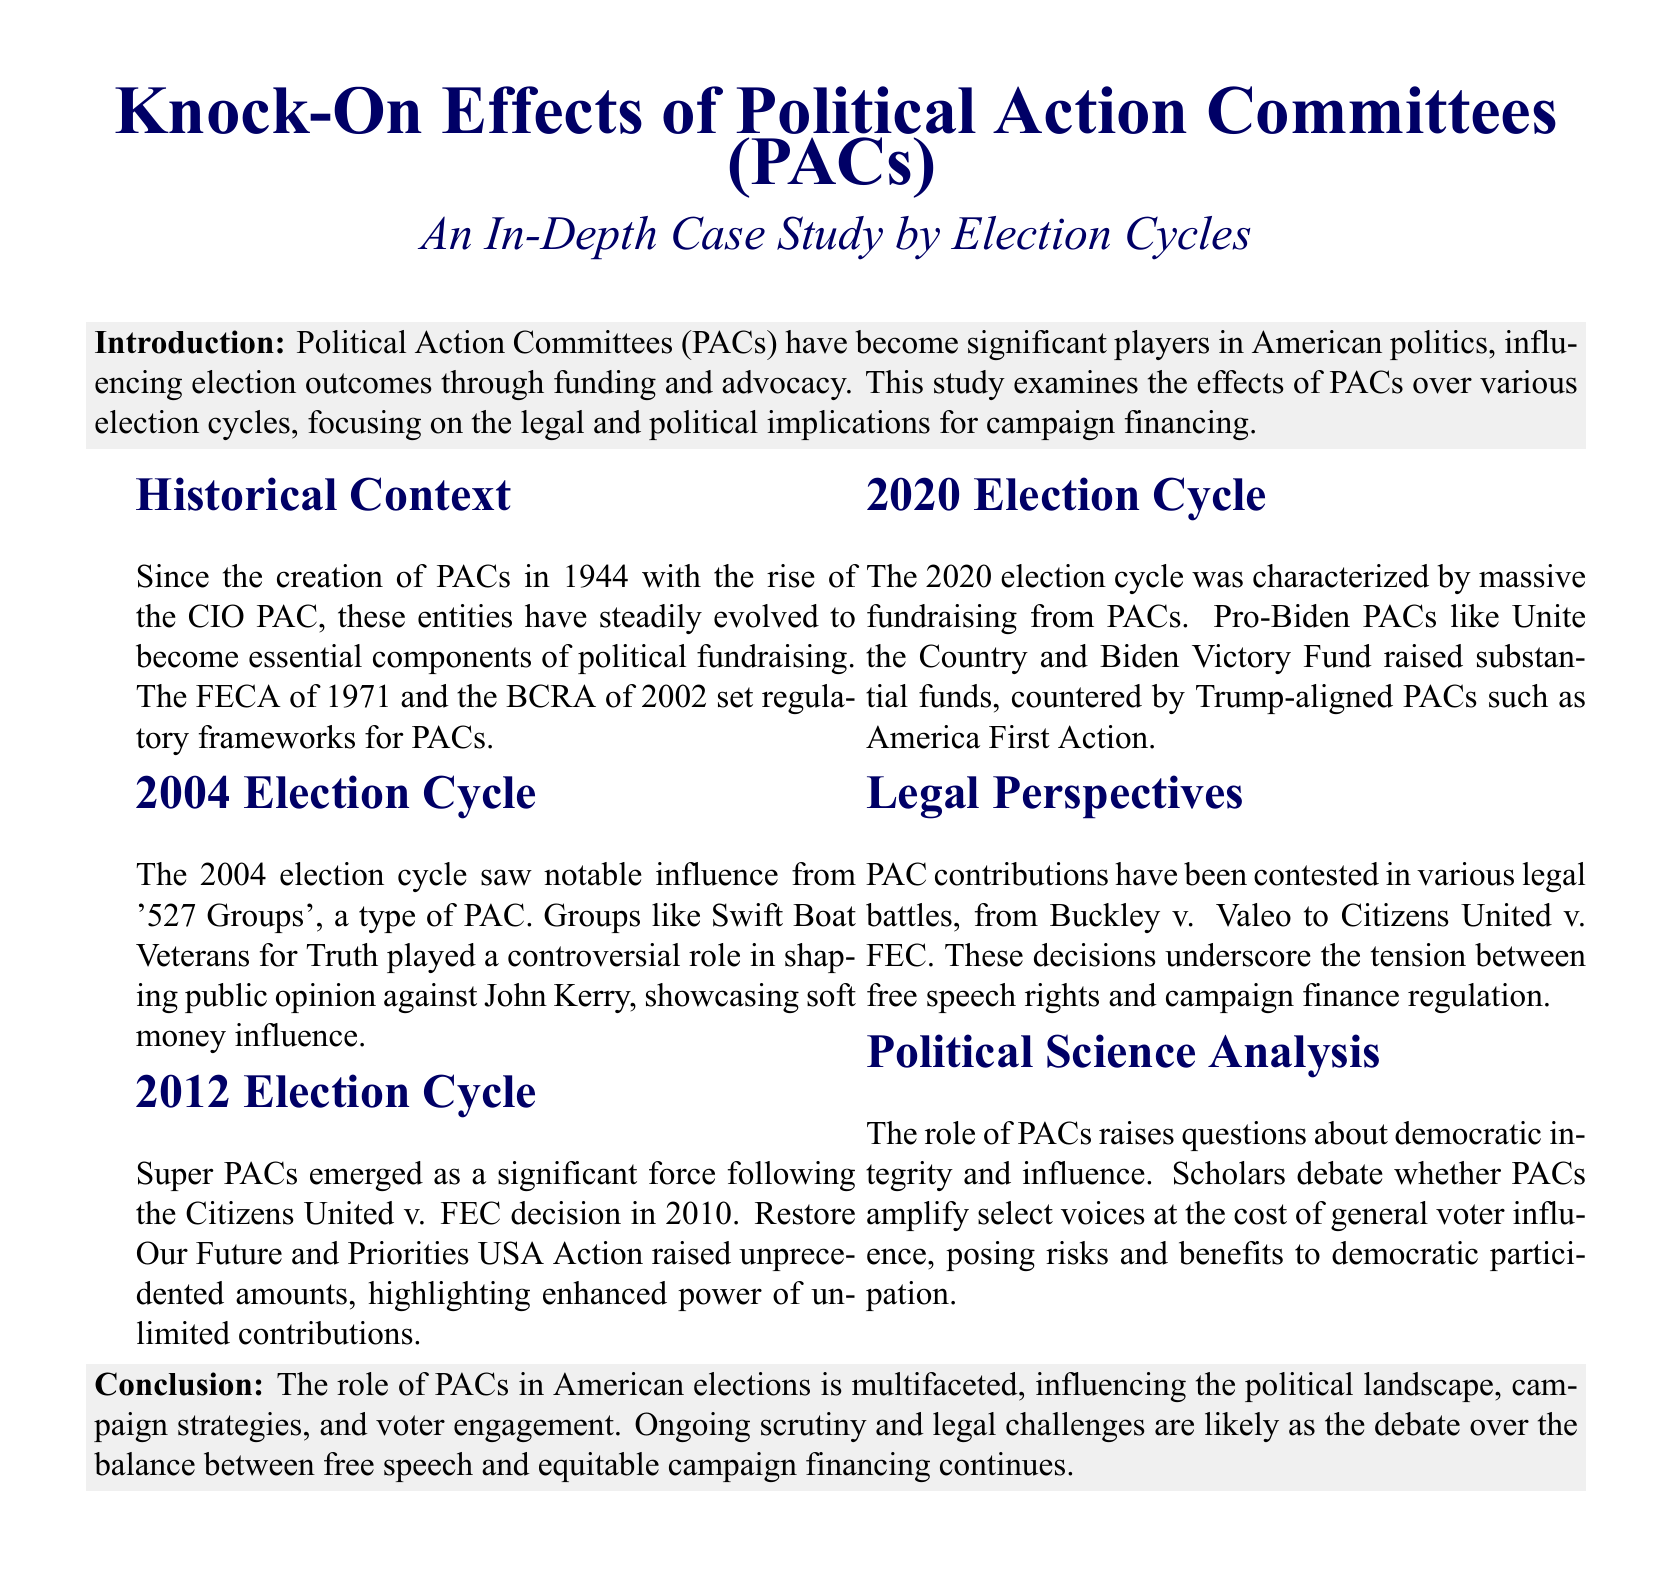What year did PACs originate? The document states that PACs were created in 1944 with the rise of the CIO PAC.
Answer: 1944 What legal case highlighted the power of Super PACs? The case of Citizens United v. FEC, mentioned in the document, underscored the enhanced power of Super PACs.
Answer: Citizens United v. FEC Which PACs were significant in the 2020 election cycle? The document mentions Pro-Biden PACs like Unite the Country and Trump-aligned PACs such as America First Action.
Answer: Unite the Country and America First Action What framework regulates PACs established in 1971? The document notes the Federal Election Campaign Act (FECA) of 1971 established a regulatory framework for PACs.
Answer: FECA What was the role of '527 Groups' in the 2004 election cycle? According to the document, '527 Groups' like Swift Boat Veterans for Truth played a controversial role against John Kerry.
Answer: Controversial role against John Kerry What ongoing issue is mentioned regarding PACs? The document refers to ongoing scrutiny and legal challenges over the debate between free speech and equitable campaign financing.
Answer: Free speech and equitable campaign financing How do PACs affect democratic participation? The document indicates that scholars debate whether PACs amplify select voices at the cost of general voter influence.
Answer: Amplify select voices What was a key characteristic of the 2012 election cycle? The emergence of Super PACs following a key legal decision signifies a notable characteristic of the 2012 election cycle.
Answer: Emergence of Super PACs 